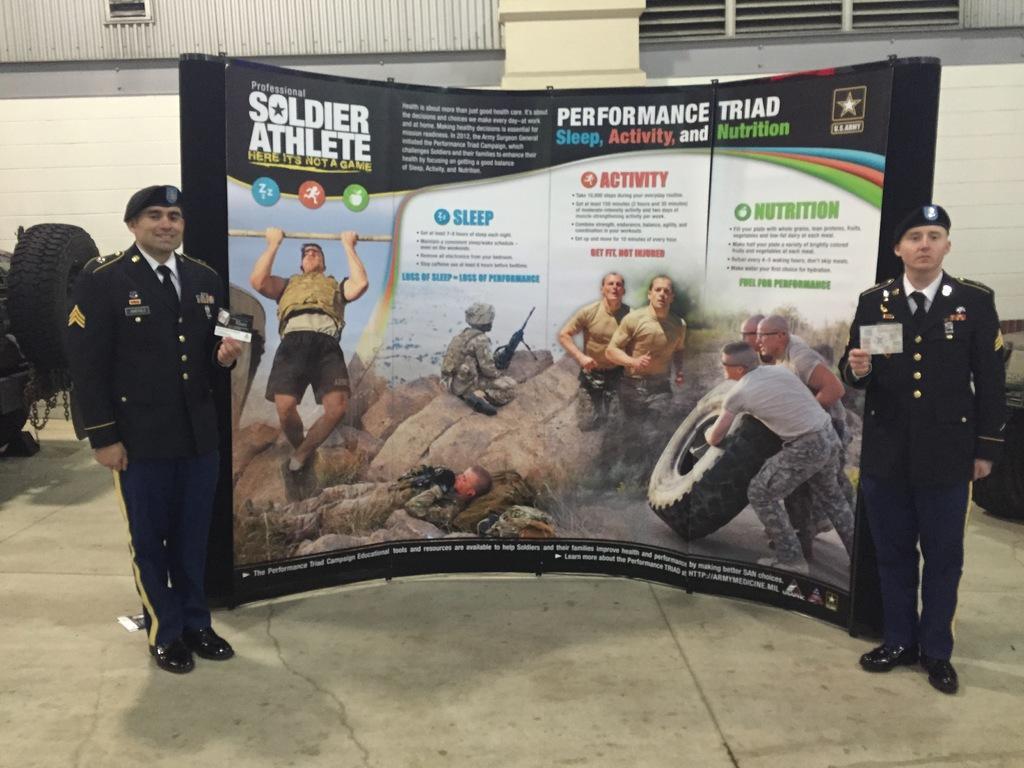Could you give a brief overview of what you see in this image? In the middle of the image two persons are standing and holding a paper. Behind them there is a banner. Behind the banner there's a wall and there are some wheels. 